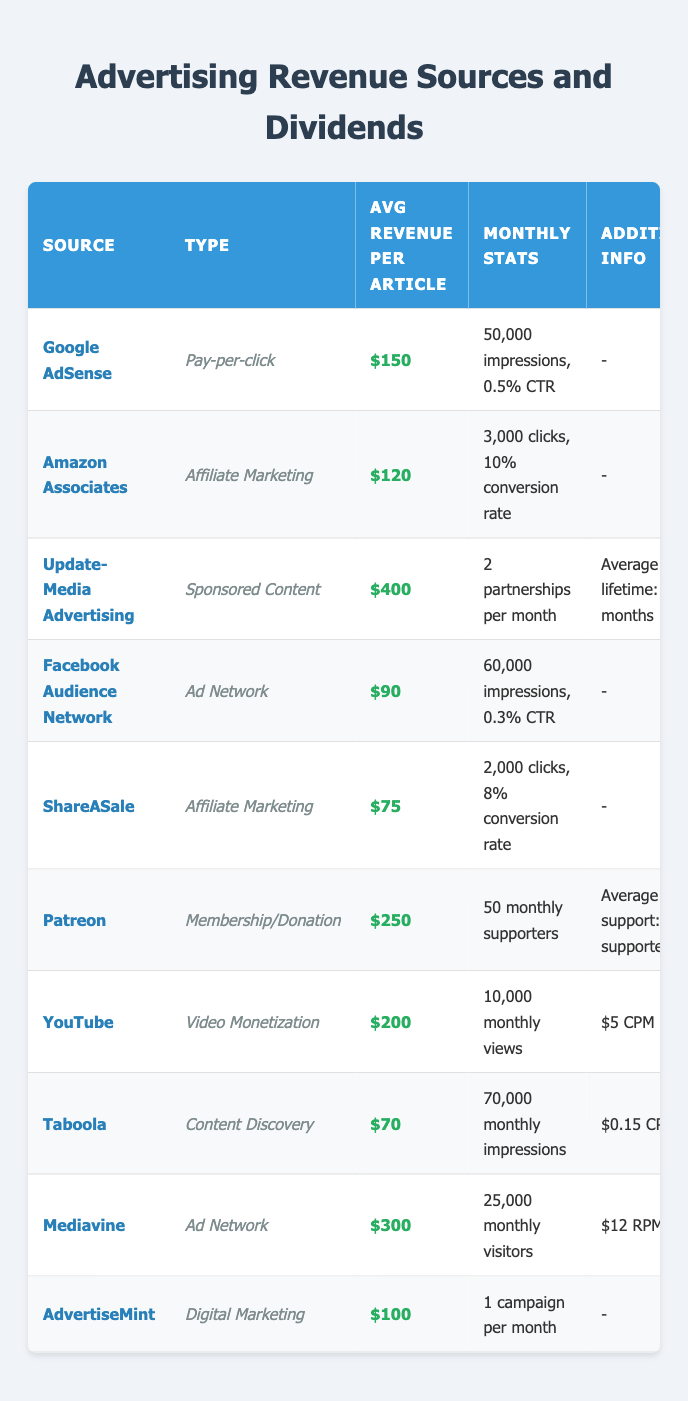What is the average revenue per article for Google AdSense? The table shows that the average revenue per article for Google AdSense is $150.
Answer: $150 How many monthly impressions does Facebook Audience Network receive? The data indicates that Facebook Audience Network has 60,000 monthly impressions.
Answer: 60,000 What is the payment method for Amazon Associates? According to the table, Amazon Associates uses Direct Deposit as its payment method.
Answer: Direct Deposit Which advertising source has the highest average revenue per article? Update-Media Advertising has the highest average revenue per article at $400.
Answer: $400 How many monthly supporters does Patreon have? The table states that Patreon has 50 monthly supporters.
Answer: 50 What is the conversion rate for ShareASale? The conversion rate for ShareASale is indicated as 8% in the table.
Answer: 8% What is the payout threshold for Mediavine? The payout threshold for Mediavine is $25, as shown in the table.
Answer: $25 Is Taboola's average revenue per article more or less than $80? The average revenue per article for Taboola is $70, which is less than $80.
Answer: Less What is the total average revenue per article for all affiliate marketing sources? The average revenues for affiliate marketing sources are Amazon Associates ($120) and ShareASale ($75). Summing them, we get $120 + $75 = $195. The average for two sources is $195 / 2 = $97.50.
Answer: $97.50 Which payment methods are used by both Google AdSense and Facebook Audience Network? Both Google AdSense and Facebook Audience Network use Bank Transfer as their payment method, as shown in the table.
Answer: Bank Transfer If a writer publishes four articles with Update-Media Advertising, what is the total revenue from those articles? The average revenue per article for Update-Media Advertising is $400. For four articles, the total revenue is $400 * 4 = $1600.
Answer: $1600 Is the average revenue per article for YouTube greater than or equal to $200? The average revenue per article for YouTube is $200, which is equal to $200.
Answer: Yes What is the average payout threshold of all the advertising sources listed in the table? The payout thresholds are $100, $10, $500, $100, $50, $0, $100, $100, $25, and $200. Calculate the average: ($100 + $10 + $500 + $100 + $50 + $0 + $100 + $100 + $25 + $200) / 10 = $1885 / 10 = $188.50.
Answer: $188.50 How many times more revenue per article does Update-Media Advertising generate compared to Taboola? Update-Media Advertising generates $400 per article while Taboola generates $70 per article. The ratio is $400 / $70 = 5.71, so it generates approximately 5.71 times more revenue.
Answer: Approximately 5.71 times more Which types of advertising sources have a payout threshold of $100? Google AdSense, Facebook Audience Network, YouTube, and Taboola all have a payout threshold of $100, as indicated in the table.
Answer: Google AdSense, Facebook Audience Network, YouTube, Taboola 